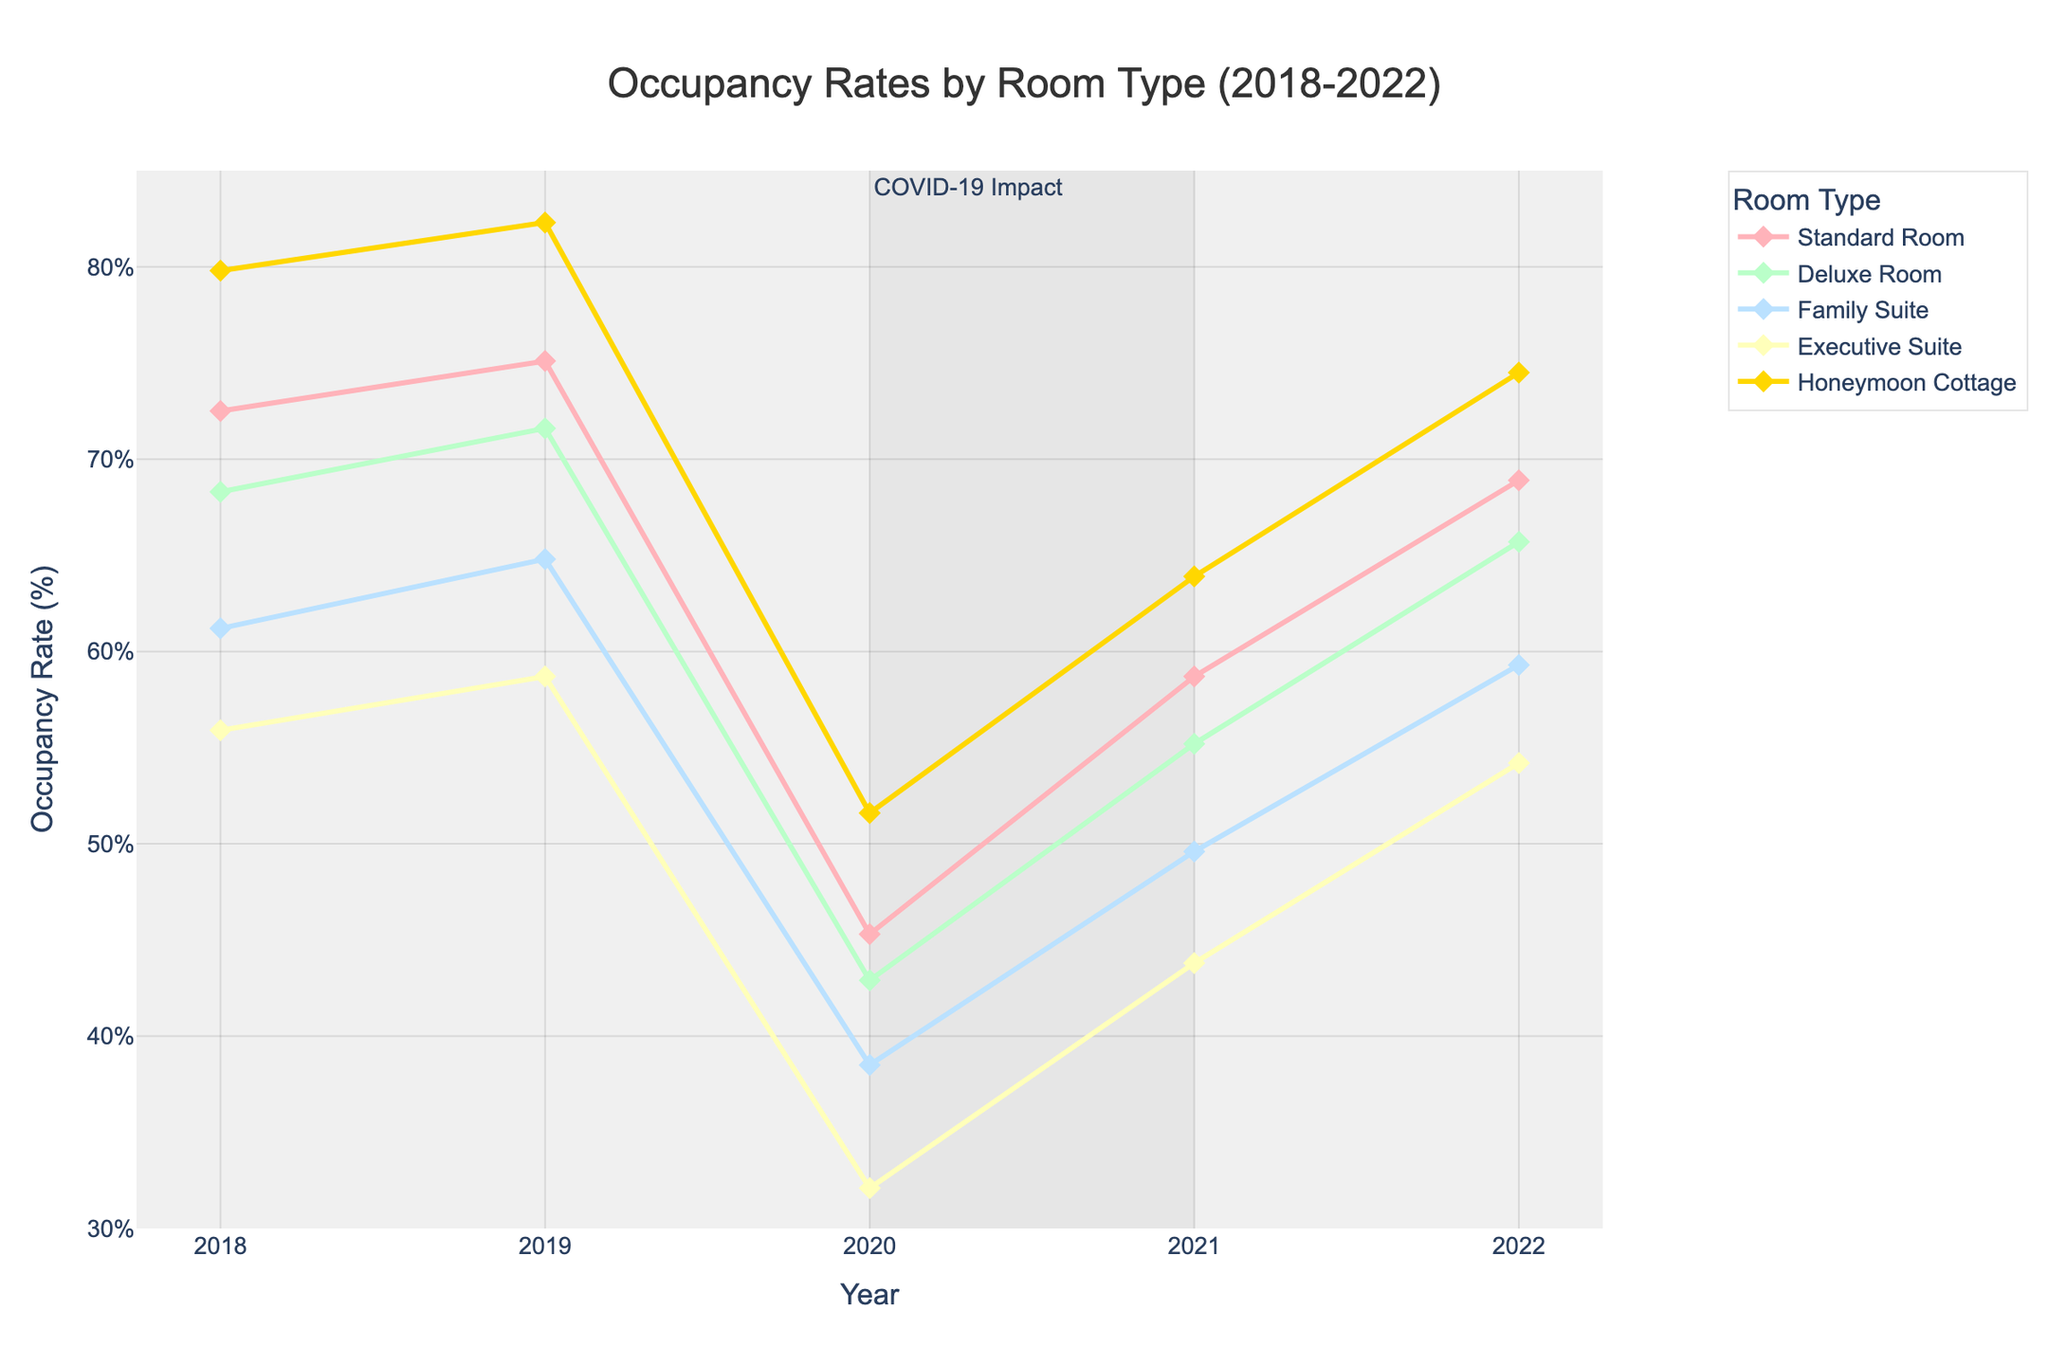What year saw the highest occupancy rate in the Honeymoon Cottage? By examining the line plot for the Honeymoon Cottage, identify the peak value. The year associated with this peak value is the answer. In the Honeymoon Cottage line, the highest point is at 2022 with a rate of 74.5%.
Answer: 2022 Which room type had the lowest occupancy rate in 2020? Compare the occupancy rates of all room types in 2020. Identify the lowest value among these rates. The Executive Suite had the lowest rate in 2020, which is 32.1%.
Answer: Executive Suite What is the average occupancy rate of the Family Suite over the 5 years? Calculate the sum of occupancy rates for Family Suite from 2018 to 2022 and divide by 5. The rates are 61.2%, 64.8%, 38.5%, 49.6%, and 59.3%. The sum is 273.4%, and the average is 273.4% / 5 = 54.68%.
Answer: 54.68% How did the occupancy rate change for the Standard Room from 2019 to 2020? Find the occupancy rates of the Standard Room for 2019 and 2020, then subtract the 2020 rate from the 2019 rate. The rates are 75.1% in 2019 and 45.3% in 2020. The difference is 75.1% - 45.3% = 29.8%.
Answer: Decreased by 29.8% In which year did the Deluxe Room see its highest increase in occupancy rate compared to the previous year? Compare the year-to-year differences for the Deluxe Room occupancy rates. The increases are from 68.3% to 71.6% in 2019, 42.9% in 2020, 55.2% in 2021, and 65.7% in 2022. The highest increase occurred from 2020 to 2021 (12.3%).
Answer: 2021 Which room types had a recovery in occupancy rate in 2021 after a decline in 2020? Check the occupancy rates for all room types for the years 2020 and 2021 to see which ones had lower rates in 2020 and higher in 2021. All room types (Standard Room, Deluxe Room, Family Suite, Executive Suite, and Honeymoon Cottage) demonstrated this pattern.
Answer: All room types What is the overall trend in occupancy rates for the Executive Suite from 2018 to 2022? Observe the line plot of the Executive Suite from 2018 to 2022. Initially, there is a decline from 55.9% in 2018 to 32.1% in 2020, followed by an increase to 54.2% in 2022. The overall trend shows a decline first and then a recovery.
Answer: Decline then recovery Which room type consistently had the highest occupancy rate each year? By observing each line at the highest point for every year, identify the room type. The Honeymoon Cottage line always represents the highest value in each year from 2018 to 2022.
Answer: Honeymoon Cottage 